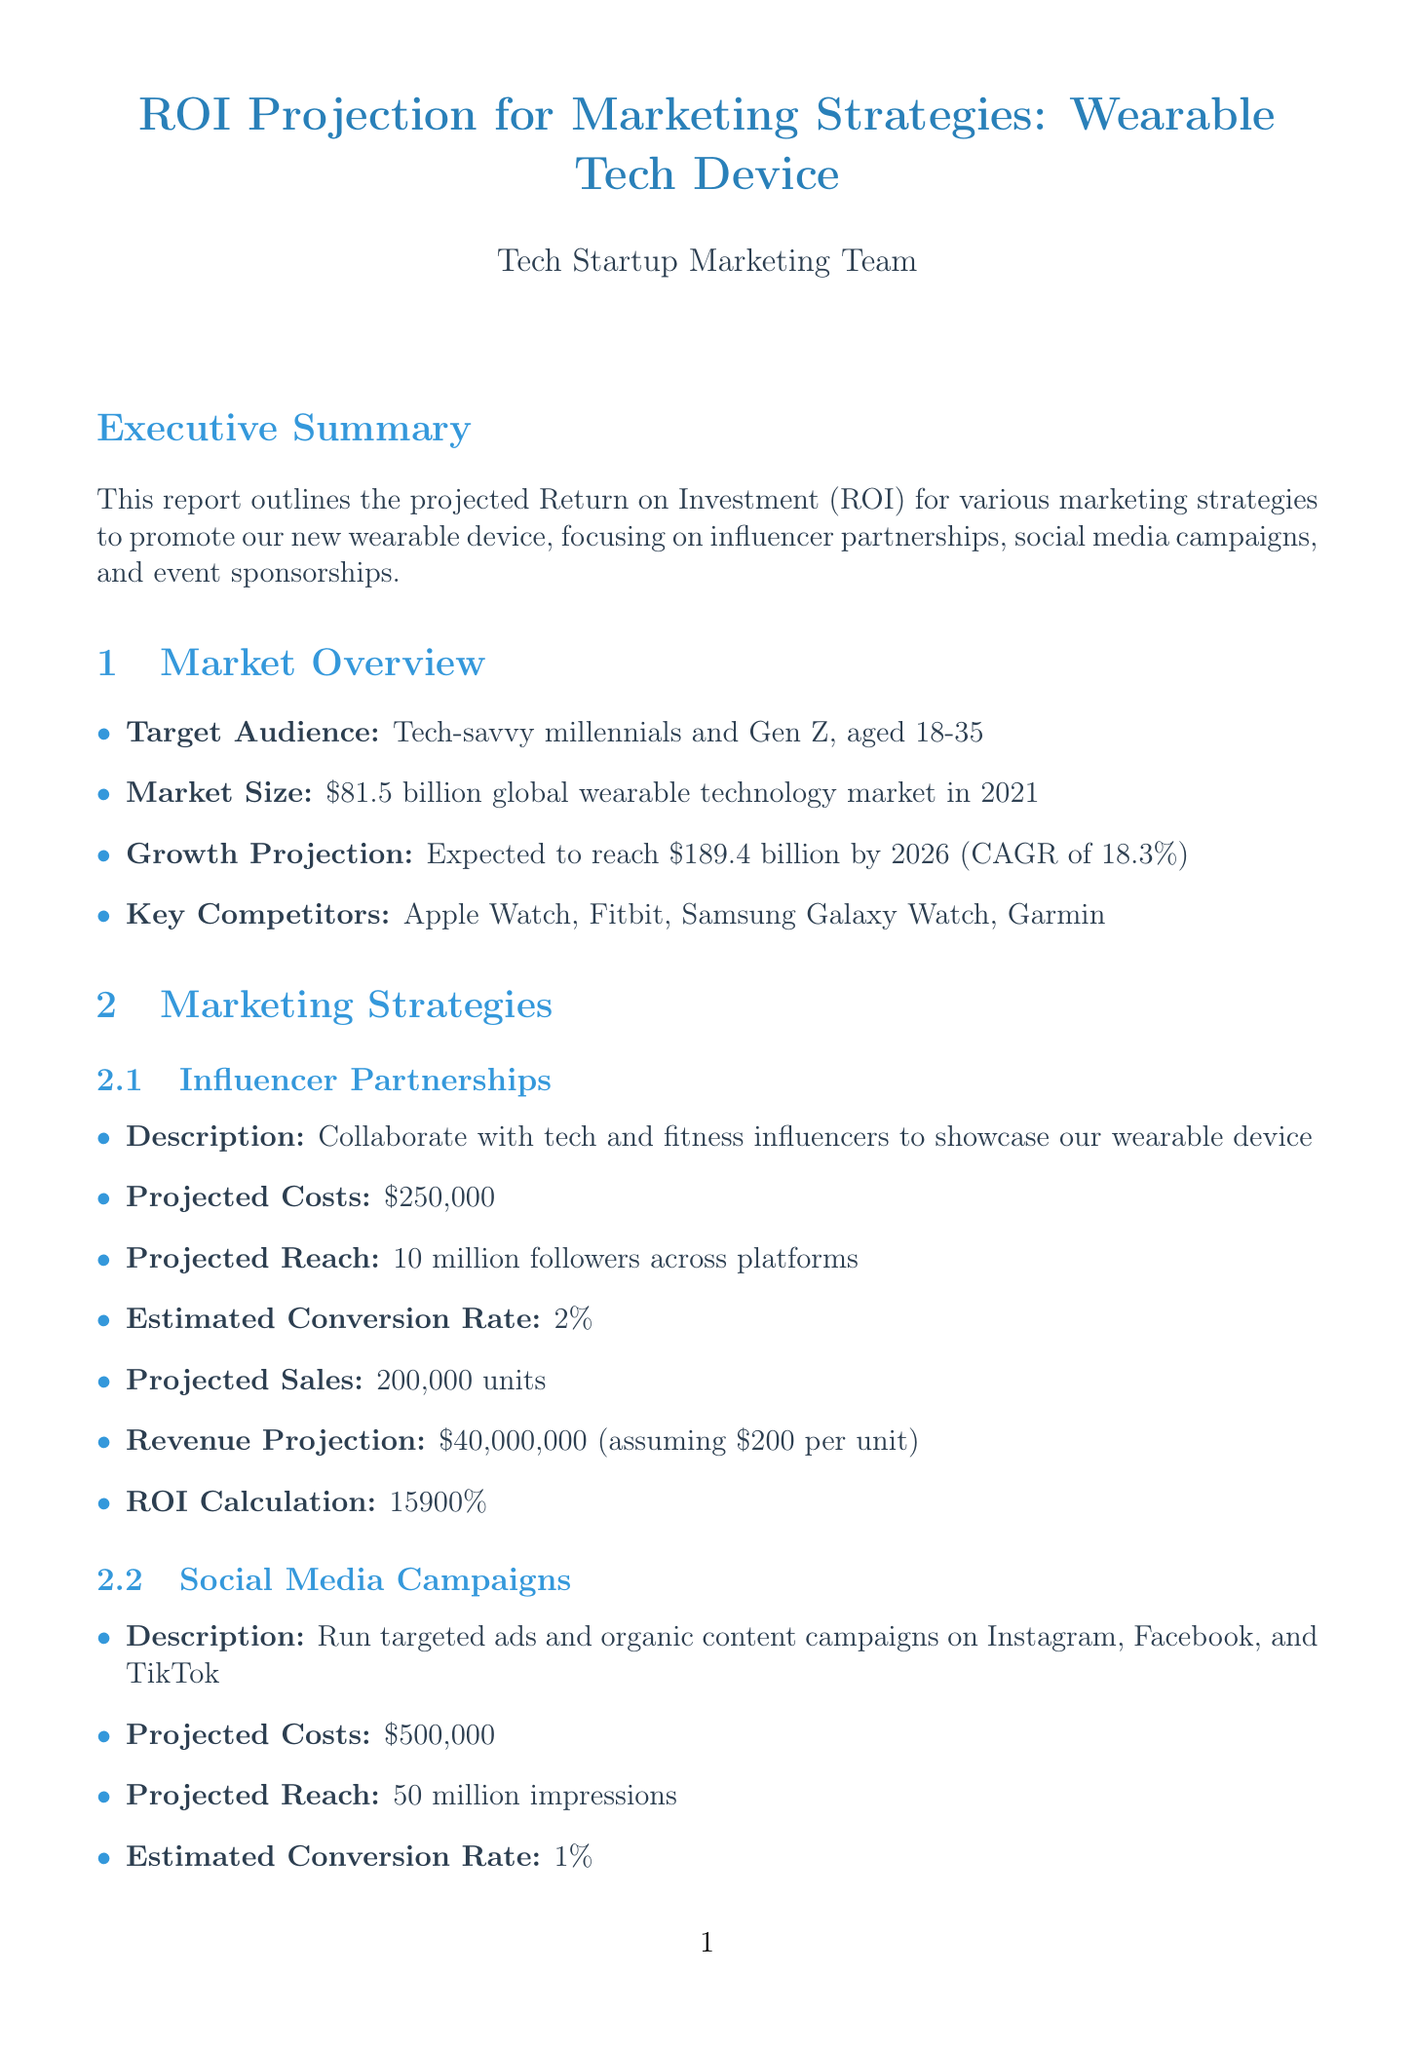what is the total projected cost for influencer partnerships? The total projected cost for influencer partnerships is listed in the document as $250,000.
Answer: $250,000 what is the estimated conversion rate for social media campaigns? The estimated conversion rate is specified within the social media campaigns section.
Answer: 1% which marketing strategy has the highest ROI? The document explicitly states that social media campaigns have the highest ROI percentage.
Answer: 19900% how many units are projected to be sold through influencer partnerships? The projected sales for influencer partnerships can be found in the specific strategy section.
Answer: 200,000 units what is the total duration of the evaluation phase? The duration for the evaluation phase is provided in the implementation timeline section.
Answer: 1 month what is the best long-term impact strategy according to the report? The report identifies the strategy with the best long-term impact in the comparative analysis section.
Answer: Influencer Partnerships what are the major competitors listed in the market overview? The list of key competitors is included in the market overview section of the report.
Answer: Apple Watch, Fitbit, Samsung Galaxy Watch, Garmin what type of risk is associated with influencer partnerships? The risk assessment section names the specific risk tied to influencer partnerships.
Answer: Influencer controversy what is the projected reach for event sponsorships? The projected reach for event sponsorships is noted in the marketing strategies section.
Answer: 1 million direct interactions 